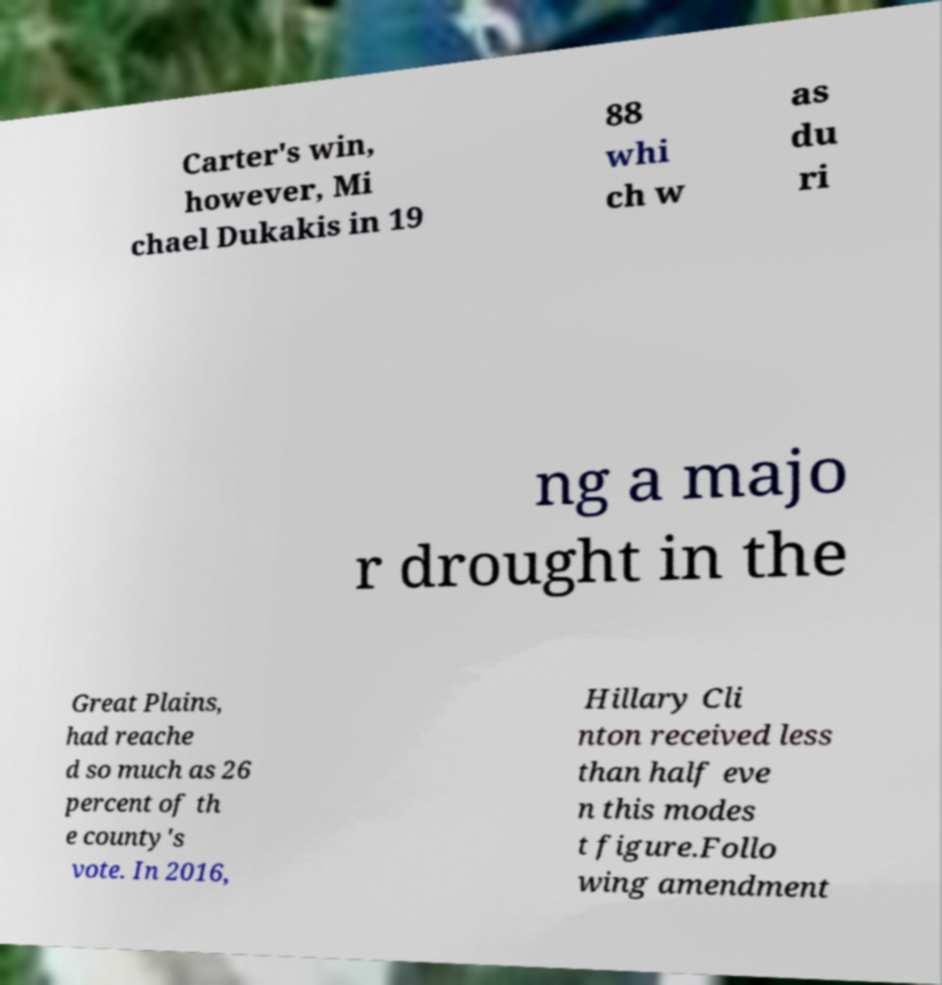Could you extract and type out the text from this image? Carter's win, however, Mi chael Dukakis in 19 88 whi ch w as du ri ng a majo r drought in the Great Plains, had reache d so much as 26 percent of th e county's vote. In 2016, Hillary Cli nton received less than half eve n this modes t figure.Follo wing amendment 